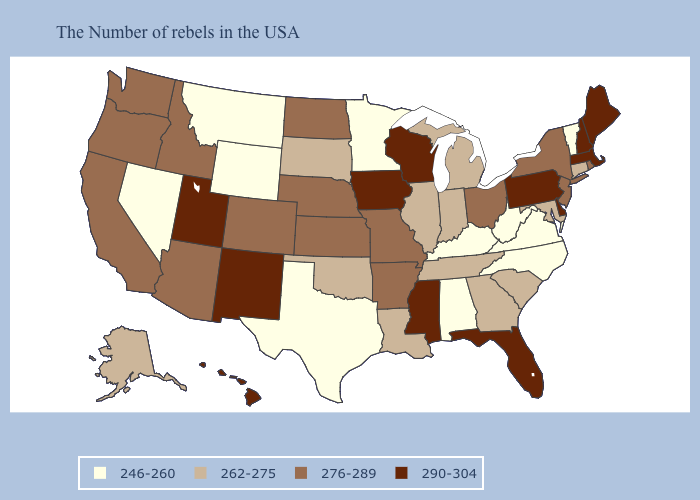Does Delaware have the lowest value in the USA?
Quick response, please. No. What is the highest value in the MidWest ?
Write a very short answer. 290-304. What is the lowest value in states that border Virginia?
Quick response, please. 246-260. Name the states that have a value in the range 246-260?
Concise answer only. Vermont, Virginia, North Carolina, West Virginia, Kentucky, Alabama, Minnesota, Texas, Wyoming, Montana, Nevada. Among the states that border Vermont , does New York have the lowest value?
Concise answer only. Yes. Which states have the lowest value in the USA?
Give a very brief answer. Vermont, Virginia, North Carolina, West Virginia, Kentucky, Alabama, Minnesota, Texas, Wyoming, Montana, Nevada. What is the value of Oregon?
Concise answer only. 276-289. What is the lowest value in the USA?
Give a very brief answer. 246-260. Does the first symbol in the legend represent the smallest category?
Be succinct. Yes. Name the states that have a value in the range 262-275?
Write a very short answer. Connecticut, Maryland, South Carolina, Georgia, Michigan, Indiana, Tennessee, Illinois, Louisiana, Oklahoma, South Dakota, Alaska. Name the states that have a value in the range 290-304?
Concise answer only. Maine, Massachusetts, New Hampshire, Delaware, Pennsylvania, Florida, Wisconsin, Mississippi, Iowa, New Mexico, Utah, Hawaii. What is the lowest value in states that border Mississippi?
Quick response, please. 246-260. Does Florida have the highest value in the USA?
Keep it brief. Yes. 